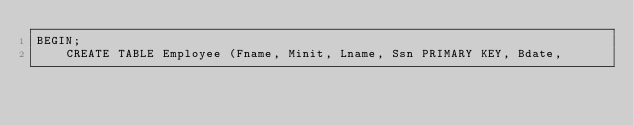Convert code to text. <code><loc_0><loc_0><loc_500><loc_500><_SQL_>BEGIN;
    CREATE TABLE Employee (Fname, Minit, Lname, Ssn PRIMARY KEY, Bdate,</code> 